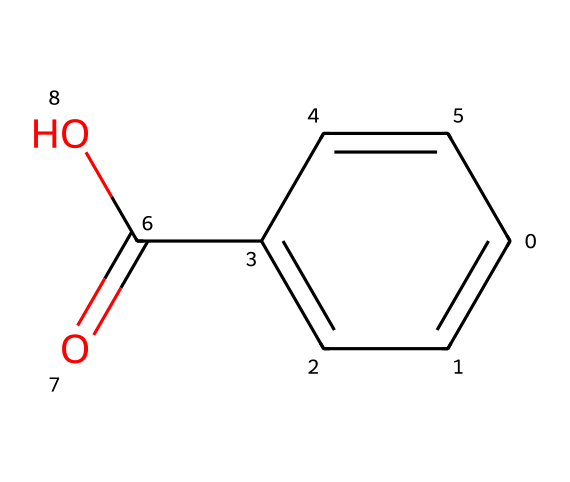What is the molecular formula of this chemical? To find the molecular formula, count the number of each type of atom in the structure. The SMILES indicates a benzene ring (C6) connected to a carboxylic acid (-COOH) group. Thus, the molecular formula is C7H6O2.
Answer: C7H6O2 How many carbon atoms are present in the structure? By analyzing the SMILES notation, we see there are 7 carbon atoms in total: 6 in the benzene ring and 1 in the carboxylic acid group.
Answer: 7 What type of functional group is found in this chemical? The structural composition shows a carboxylic acid functional group (-COOH), characterized by a carbonyl (C=O) and hydroxyl (–OH) group.
Answer: carboxylic acid What is the significance of hydroxy groups in preservatives? Hydroxy groups (-OH) increase the solubility of the chemical in water, which can enhance its effectiveness as a food preservative by allowing it to interact with microbial membranes more readily.
Answer: solubility How many double bonds are in the chemical structure? The structure contains one double bond in the carboxylic acid group (C=O). Additionally, there are also double bonds between the carbon atoms in the benzene ring, but these count as part of the aromatic system. In total, there are multiple double bonds, but distinctively here, it's mainly carbohydrate double bond of the -COOH.
Answer: 1 What does the presence of a benzene ring imply about this chemical? The presence of a benzene ring indicates that this compound is aromatic. Aromatic compounds often have stability and distinctive smells, and they play a significant role in flavor and preservation in food products.
Answer: aromatic How does this chemical help in food preservation? The carboxylic acid group in benzoic acid can inhibit the growth of molds, yeast, and some bacteria, extending the shelf life of food products.
Answer: inhibit growth 